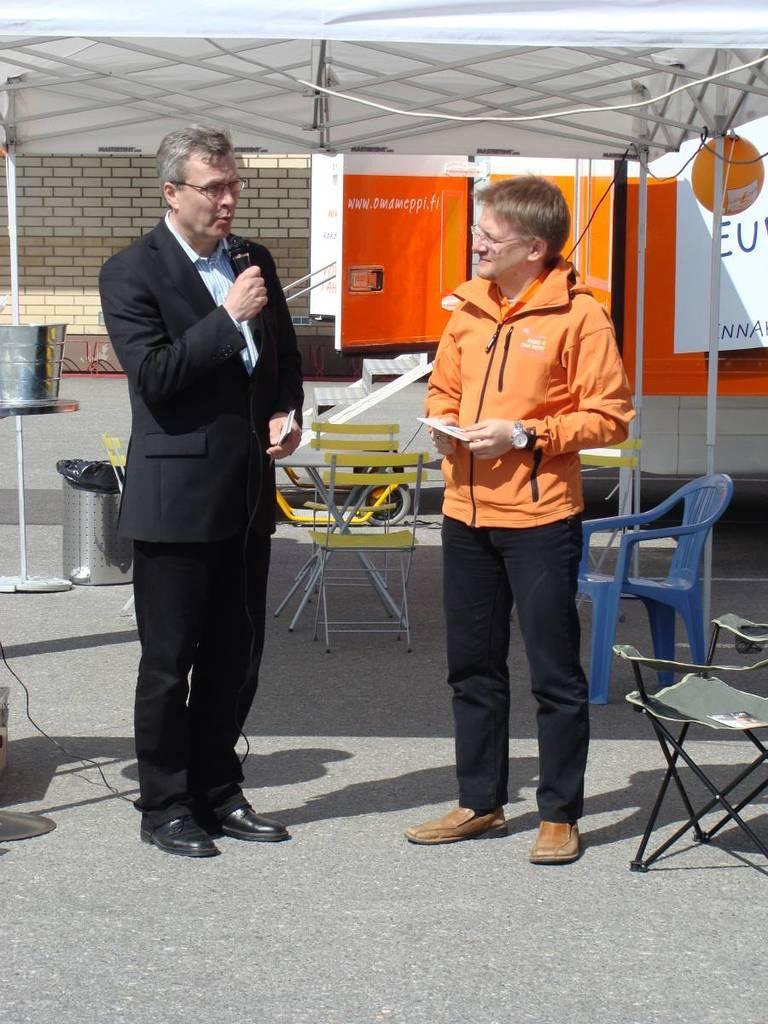In one or two sentences, can you explain what this image depicts? In the image there were two people and the left side person he is talking something and the right side person he is listening to him. The back of them there is a chair,they are under some tent. Coming to background there is a bricks wall. 